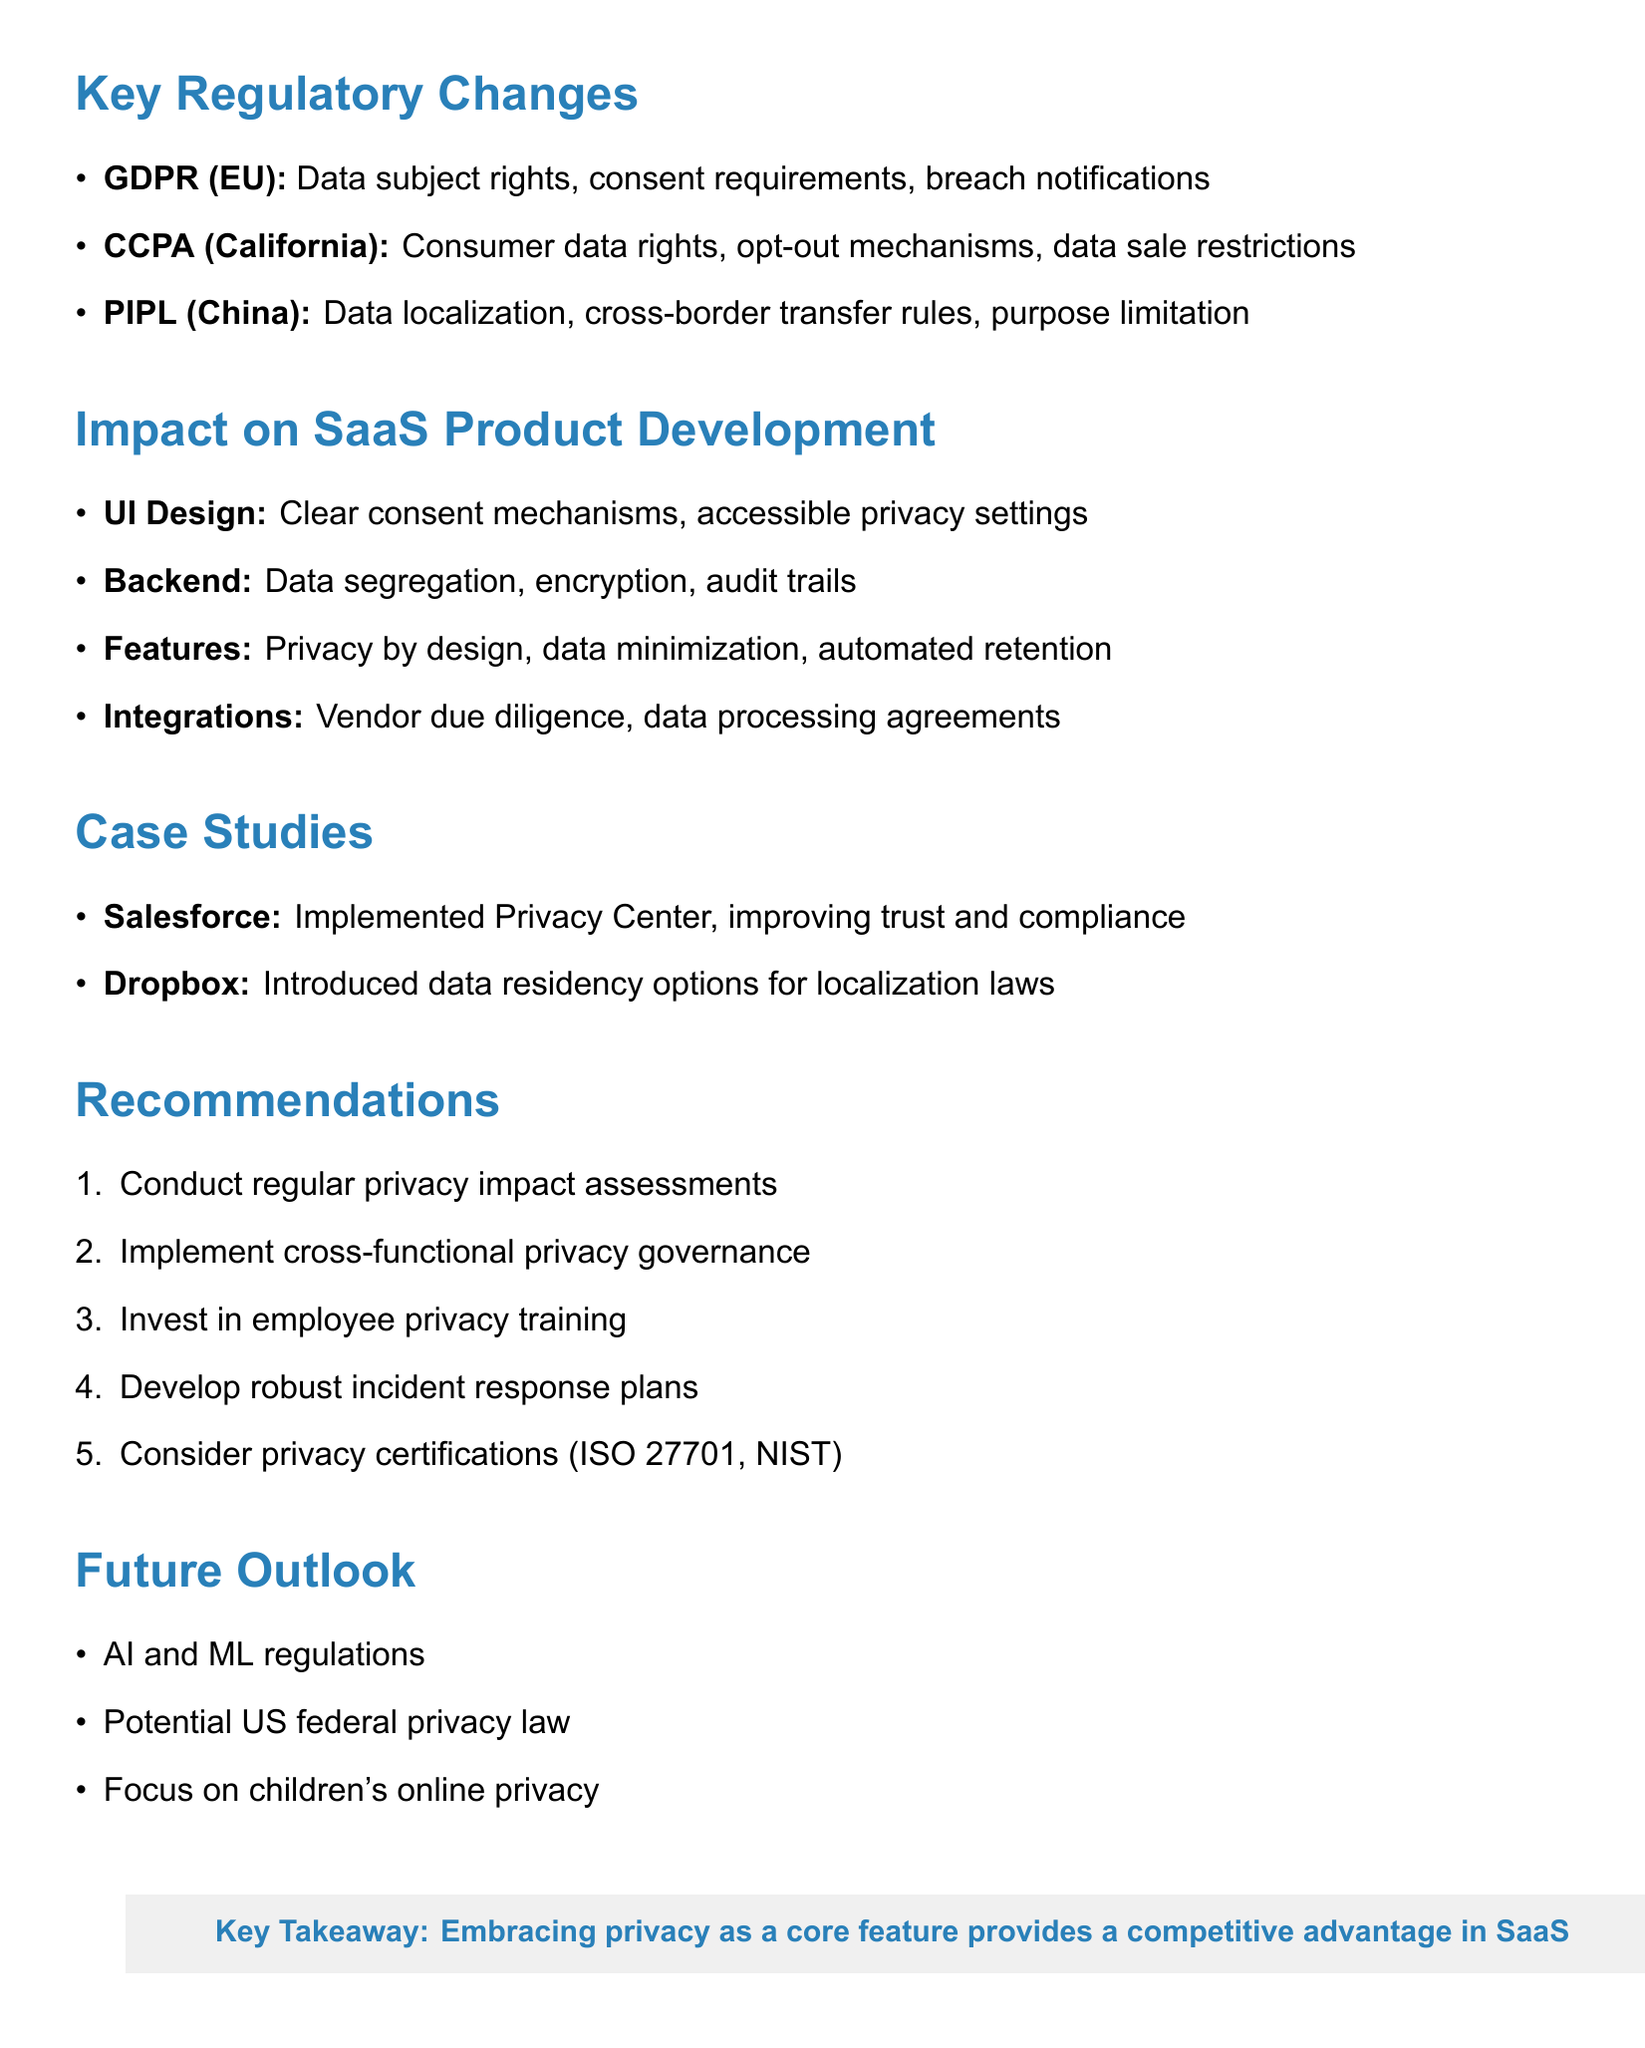What are the three major regulatory changes highlighted? The document lists GDPR, CCPA, and PIPL as the three major regulatory changes.
Answer: GDPR, CCPA, PIPL Which company implemented the Privacy Center? The case studies mention Salesforce as the company that implemented the Privacy Center.
Answer: Salesforce What area of SaaS product development focuses on clear consent mechanisms? The area of User Interface Design emphasizes clear consent mechanisms.
Answer: User Interface Design What is the key takeaway from the document? The document concludes that embracing privacy as a core feature provides a competitive advantage in SaaS.
Answer: Embracing privacy as a core feature provides a competitive advantage in SaaS What regulatory feature is specific to the California Consumer Privacy Act? The CCPA includes consumer data rights as a key feature.
Answer: Consumer data rights Which recommendation suggests conducting regular assessments? The recommendation to conduct regular privacy impact assessments directly addresses this.
Answer: Conduct regular privacy impact assessments What emerging trend relates to regulations on AI? The document notes that there is an increased focus on AI and machine learning regulations as an emerging trend.
Answer: Increased focus on AI and machine learning regulations What is one of the areas impacted by data privacy regulations? The document highlights User Interface Design as one of the areas impacted.
Answer: User Interface Design 